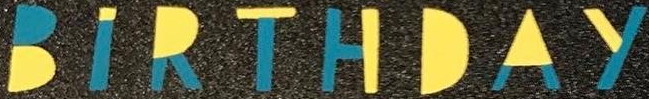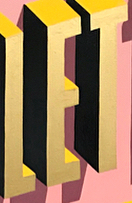What text appears in these images from left to right, separated by a semicolon? BIRTHDAY; LET 